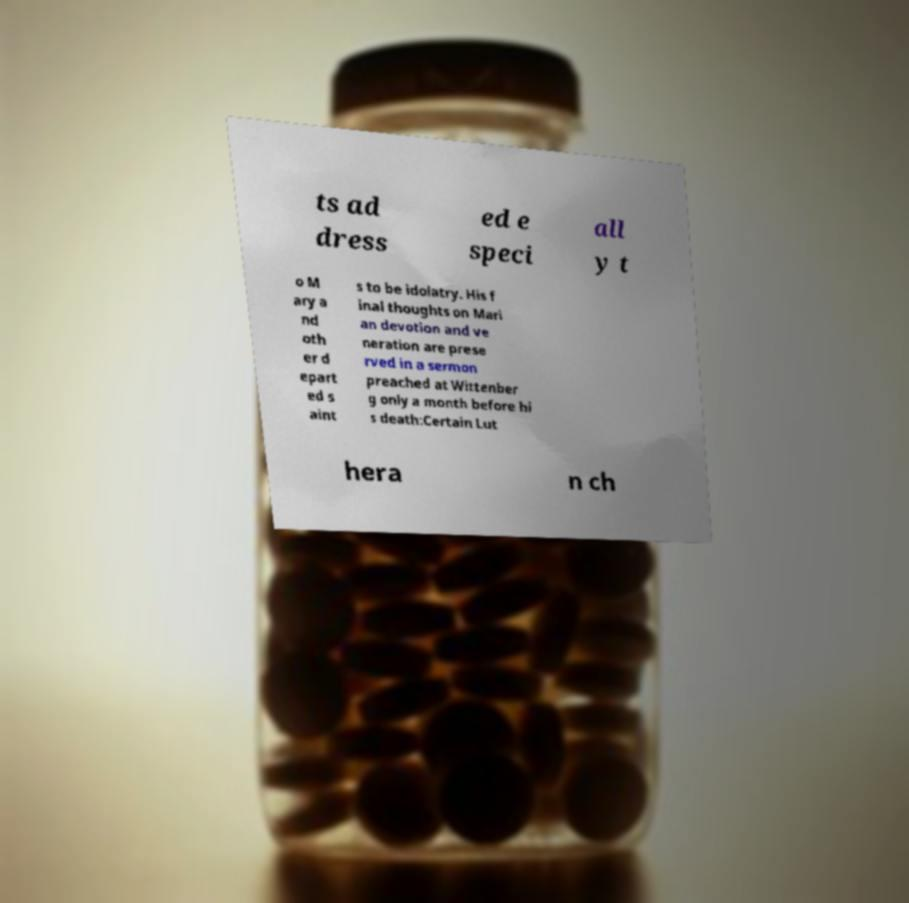There's text embedded in this image that I need extracted. Can you transcribe it verbatim? ts ad dress ed e speci all y t o M ary a nd oth er d epart ed s aint s to be idolatry. His f inal thoughts on Mari an devotion and ve neration are prese rved in a sermon preached at Wittenber g only a month before hi s death:Certain Lut hera n ch 